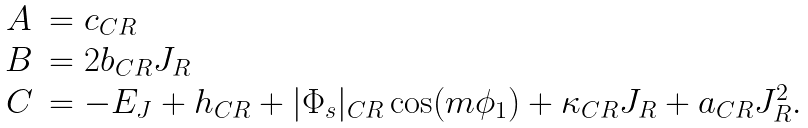Convert formula to latex. <formula><loc_0><loc_0><loc_500><loc_500>\begin{array} { c l } A & = c _ { C R } \\ B & = 2 b _ { C R } J _ { R } \\ C & = - E _ { J } + h _ { C R } + | \Phi _ { s } | _ { C R } \cos ( m \phi _ { 1 } ) + \kappa _ { C R } J _ { R } + a _ { C R } J _ { R } ^ { 2 } . \end{array}</formula> 